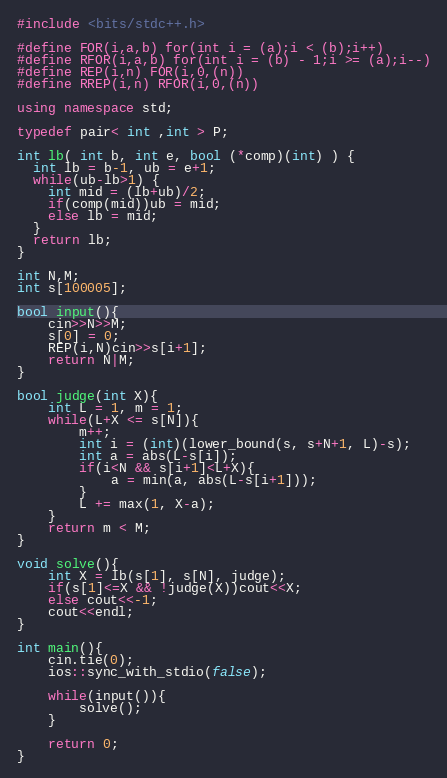Convert code to text. <code><loc_0><loc_0><loc_500><loc_500><_C++_>#include <bits/stdc++.h>

#define FOR(i,a,b) for(int i = (a);i < (b);i++)
#define RFOR(i,a,b) for(int i = (b) - 1;i >= (a);i--)
#define REP(i,n) FOR(i,0,(n))
#define RREP(i,n) RFOR(i,0,(n))

using namespace std;

typedef pair< int ,int > P;

int lb( int b, int e, bool (*comp)(int) ) {
  int lb = b-1, ub = e+1;
  while(ub-lb>1) {
  	int mid = (lb+ub)/2;
  	if(comp(mid))ub = mid;
  	else lb = mid;
  }
  return lb;
}

int N,M;
int s[100005];

bool input(){
    cin>>N>>M;
    s[0] = 0;
    REP(i,N)cin>>s[i+1];
    return N|M;
}

bool judge(int X){
    int L = 1, m = 1;
    while(L+X <= s[N]){
        m++;
        int i = (int)(lower_bound(s, s+N+1, L)-s);
        int a = abs(L-s[i]);
        if(i<N && s[i+1]<L+X){
            a = min(a, abs(L-s[i+1]));
        }
        L += max(1, X-a);
    }
    return m < M;
}

void solve(){
    int X = lb(s[1], s[N], judge);
    if(s[1]<=X && !judge(X))cout<<X;
    else cout<<-1;
    cout<<endl;
}

int main(){
    cin.tie(0);
    ios::sync_with_stdio(false);
    
    while(input()){
        solve();
    }
    
    return 0;
}</code> 